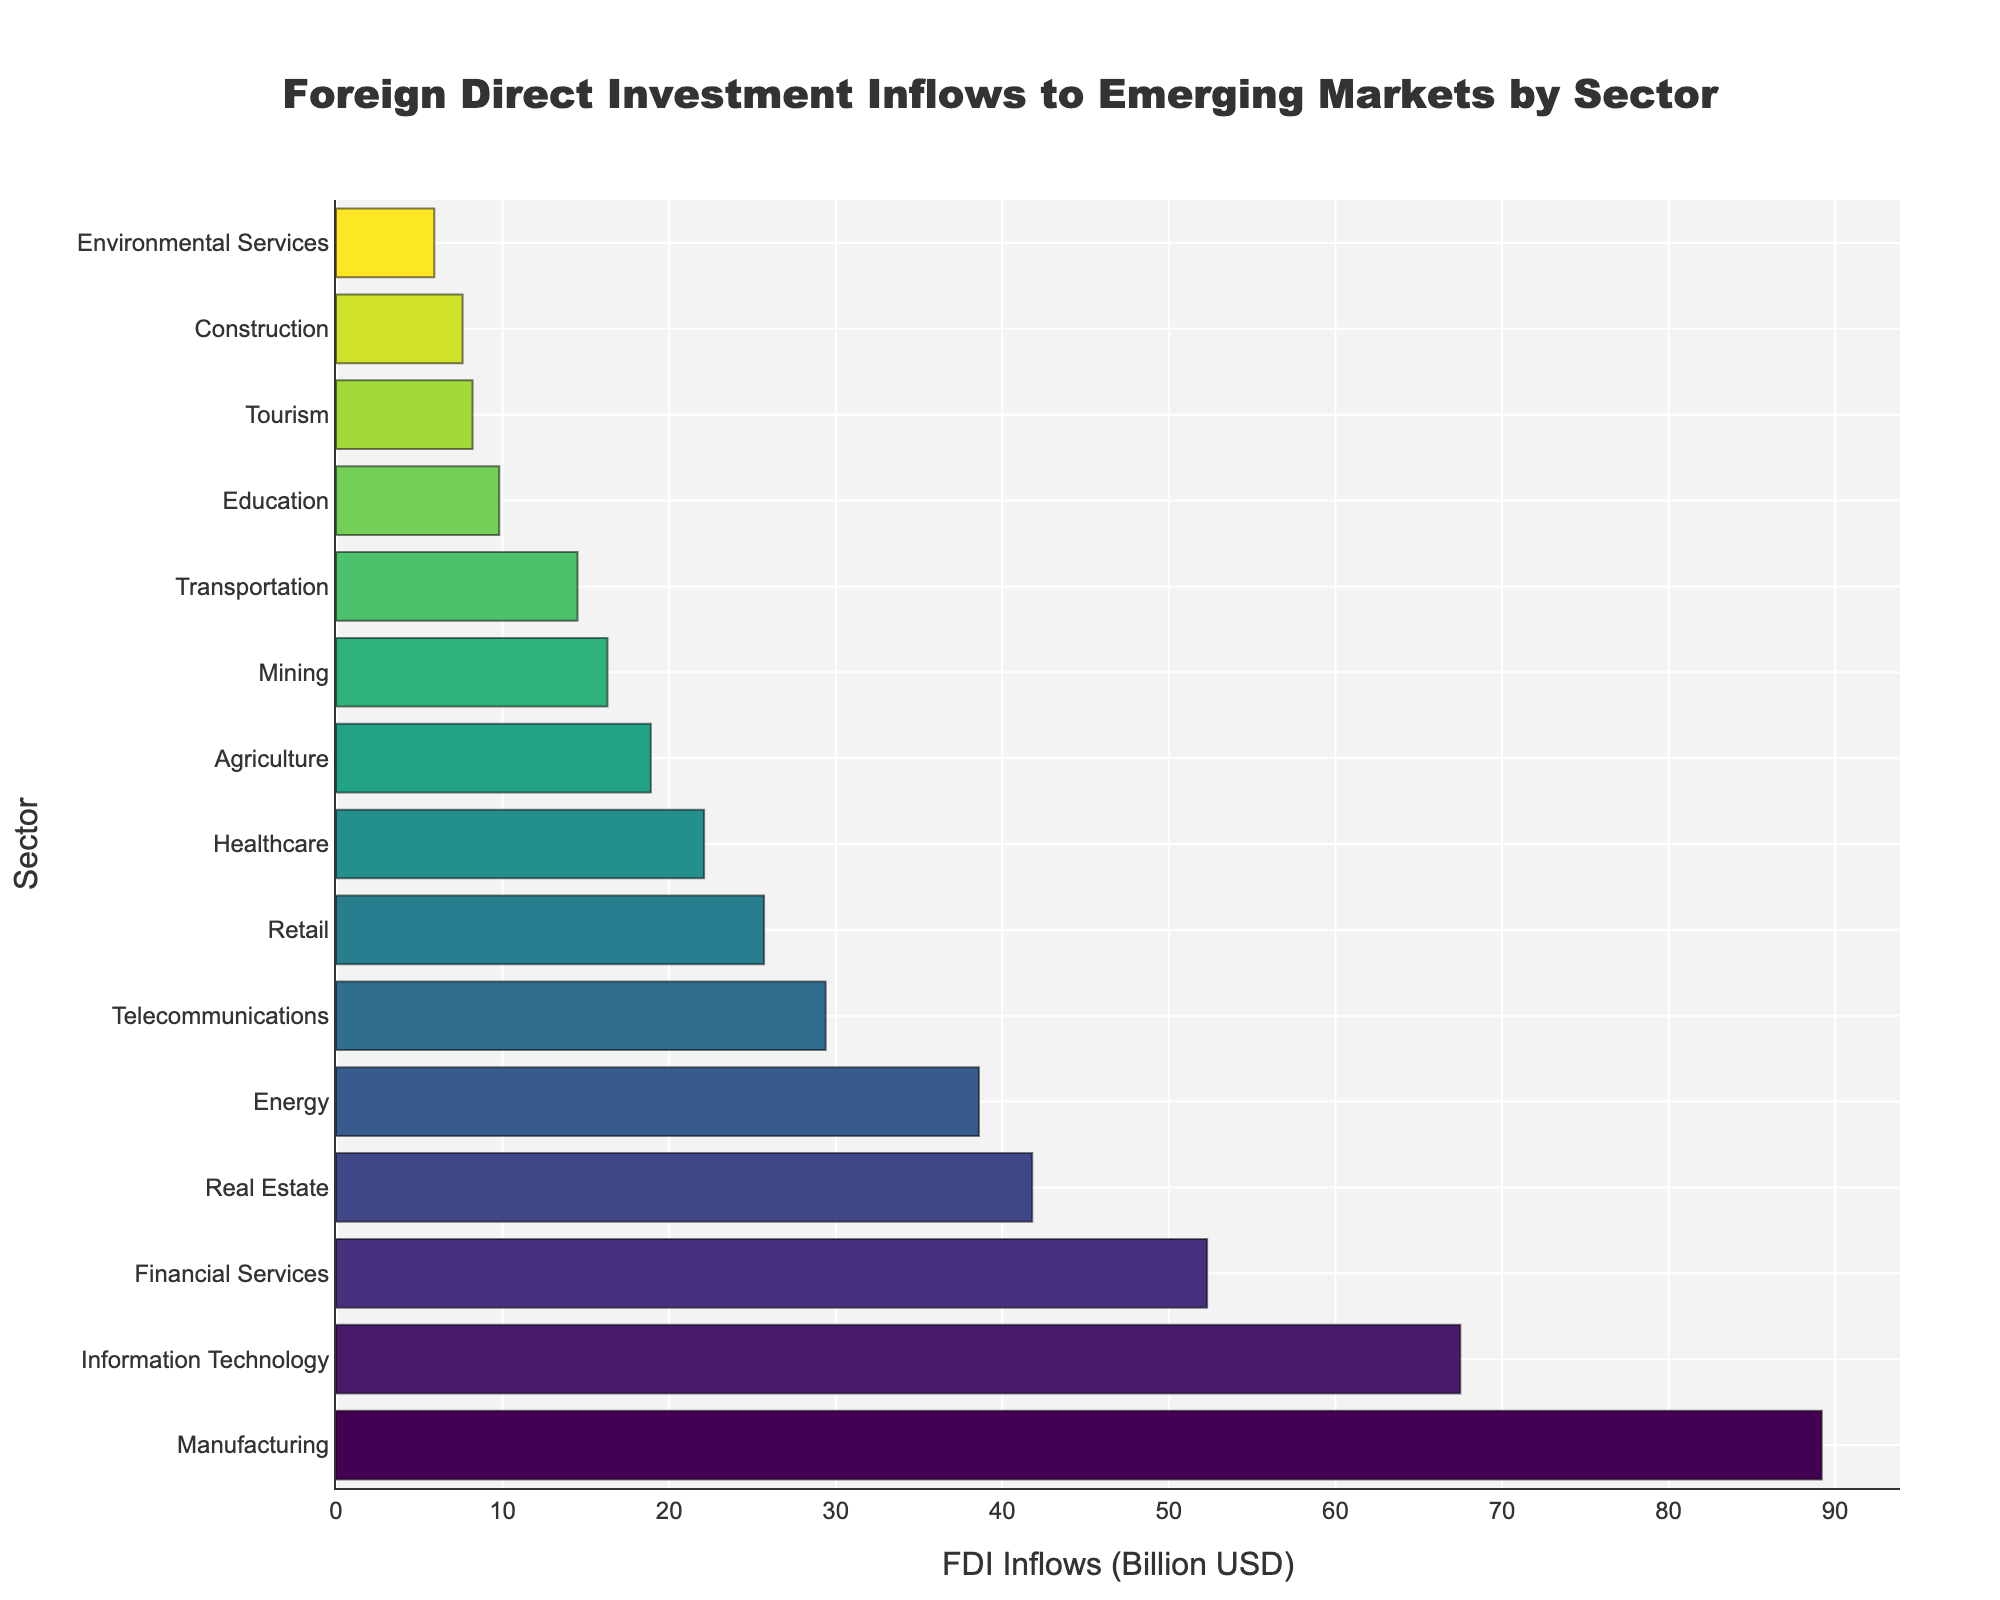What sector has the highest foreign direct investment (FDI) inflows? The sector with the highest bar represents the sector with the highest FDI inflows. Here, the bar for Manufacturing is the highest.
Answer: Manufacturing Which sector receives more FDI: Telecommunications or Agriculture? To determine which sector receives more FDI, compare the lengths of their bars. The bar for Telecommunications is longer than the bar for Agriculture.
Answer: Telecommunications What is the combined FDI inflows for Real Estate and Energy sectors? To find the combined FDI inflows, sum the values of the Real Estate and Energy sectors: Real Estate (41.8) + Energy (38.6) = 80.4
Answer: 80.4 billion USD How much more FDI does Manufacturing receive compared to Financial Services? Subtract the FDI of Financial Services from Manufacturing: 89.2 - 52.3 = 36.9
Answer: 36.9 billion USD Which sector has the lowest FDI inflows? The sector with the shortest bar represents the lowest FDI inflows. Here, the bar for Environmental Services is the shortest.
Answer: Environmental Services Is the FDI inflow in Information Technology greater than or less than the combined inflows of Healthcare and Retail? First, sum the inflows of Healthcare and Retail: Healthcare (22.1) + Retail (25.7) = 47.8. Information Technology inflows (67.5) are greater than 47.8.
Answer: Greater than What is the average FDI inflow for the top 3 sectors? Sum the FDI inflows of the top 3 sectors and divide by 3: (Manufacturing 89.2 + Information Technology 67.5 + Financial Services 52.3) / 3 = 69.67
Answer: 69.67 billion USD How does the FDI inflow in Tourism compare to Education? Compare the lengths of their bars. The bar for Education is longer than the bar for Tourism.
Answer: Less than What sectors receive between 20 and 40 billion USD in FDI inflows? Identify sectors with bars within the 20-40 billion USD range: Real Estate (41.8 is out of range), Energy (38.6), Telecommunications (29.4), Retail (25.7), Healthcare (22.1)
Answer: Energy, Telecommunications, Retail, Healthcare What is the difference in FDI inflow between the highest and the median sector? Sort the sectors by FDI inflows. The highest FDI inflow is Manufacturing (89.2). The median sector (8th in a sorted list of 15) is Healthcare (22.1). Difference is 89.2 - 22.1 = 67.1
Answer: 67.1 billion USD 